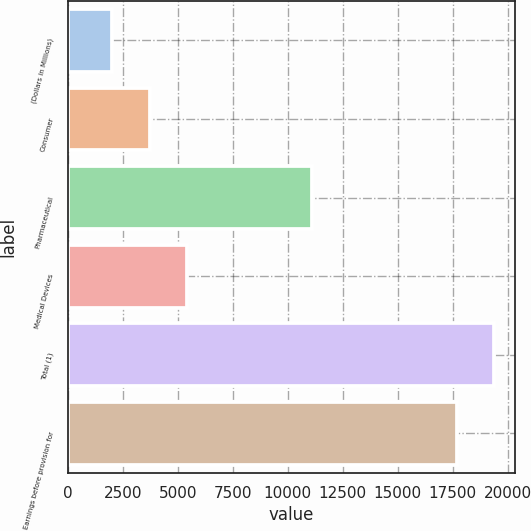<chart> <loc_0><loc_0><loc_500><loc_500><bar_chart><fcel>(Dollars in Millions)<fcel>Consumer<fcel>Pharmaceutical<fcel>Medical Devices<fcel>Total (1)<fcel>Earnings before provision for<nl><fcel>2017<fcel>3715.2<fcel>11083<fcel>5413.4<fcel>19371.2<fcel>17673<nl></chart> 